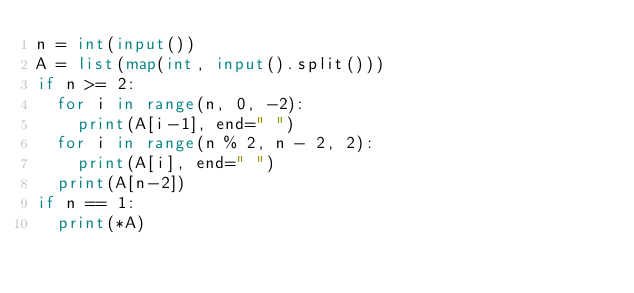Convert code to text. <code><loc_0><loc_0><loc_500><loc_500><_Python_>n = int(input())
A = list(map(int, input().split()))
if n >= 2:
  for i in range(n, 0, -2):
    print(A[i-1], end=" ")
  for i in range(n % 2, n - 2, 2):
    print(A[i], end=" ")
  print(A[n-2])
if n == 1:
  print(*A)</code> 